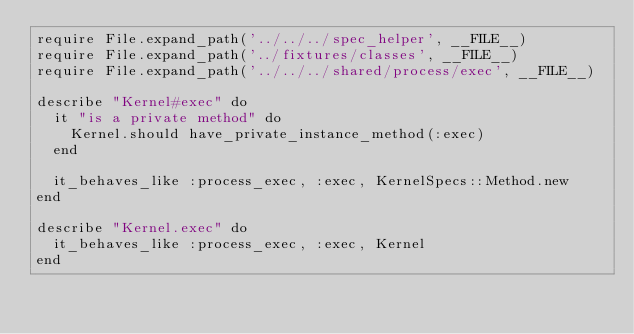Convert code to text. <code><loc_0><loc_0><loc_500><loc_500><_Ruby_>require File.expand_path('../../../spec_helper', __FILE__)
require File.expand_path('../fixtures/classes', __FILE__)
require File.expand_path('../../../shared/process/exec', __FILE__)

describe "Kernel#exec" do
  it "is a private method" do
    Kernel.should have_private_instance_method(:exec)
  end

  it_behaves_like :process_exec, :exec, KernelSpecs::Method.new
end

describe "Kernel.exec" do
  it_behaves_like :process_exec, :exec, Kernel
end
</code> 